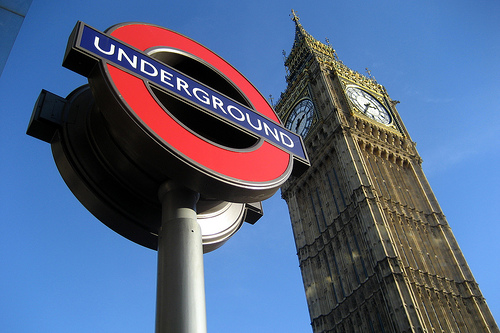<image>
Can you confirm if the sign is next to the tower? Yes. The sign is positioned adjacent to the tower, located nearby in the same general area. 